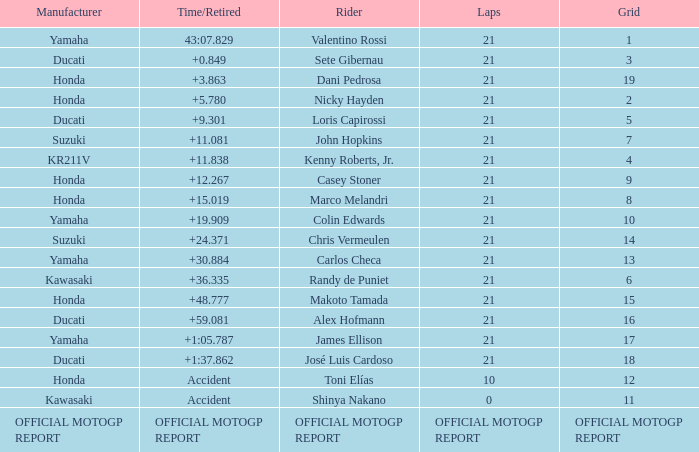When rider John Hopkins had 21 laps, what was the grid? 7.0. 